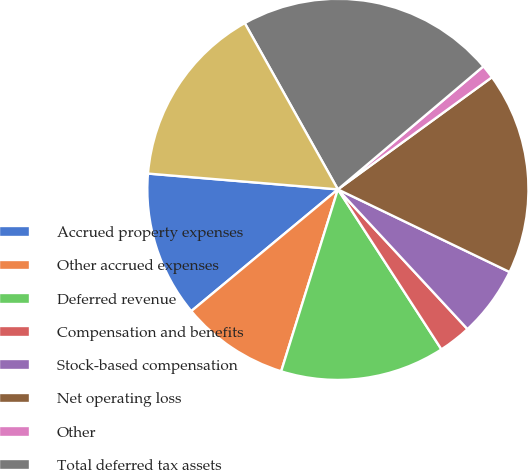<chart> <loc_0><loc_0><loc_500><loc_500><pie_chart><fcel>Accrued property expenses<fcel>Other accrued expenses<fcel>Deferred revenue<fcel>Compensation and benefits<fcel>Stock-based compensation<fcel>Net operating loss<fcel>Other<fcel>Total deferred tax assets<fcel>Valuation allowance<nl><fcel>12.35%<fcel>9.16%<fcel>13.95%<fcel>2.76%<fcel>5.96%<fcel>17.15%<fcel>1.16%<fcel>21.95%<fcel>15.55%<nl></chart> 